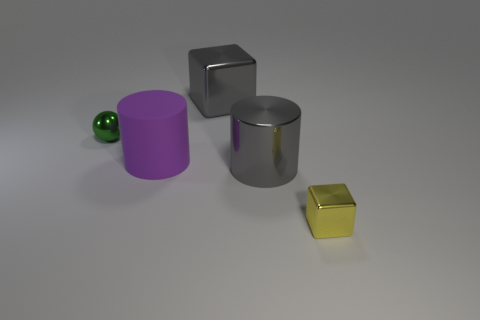Add 3 small metal blocks. How many objects exist? 8 Subtract all gray cylinders. How many cylinders are left? 1 Subtract 0 purple cubes. How many objects are left? 5 Subtract all cylinders. How many objects are left? 3 Subtract 1 balls. How many balls are left? 0 Subtract all purple balls. Subtract all green cylinders. How many balls are left? 1 Subtract all gray metallic things. Subtract all gray metal cylinders. How many objects are left? 2 Add 4 tiny yellow metal cubes. How many tiny yellow metal cubes are left? 5 Add 4 tiny brown rubber balls. How many tiny brown rubber balls exist? 4 